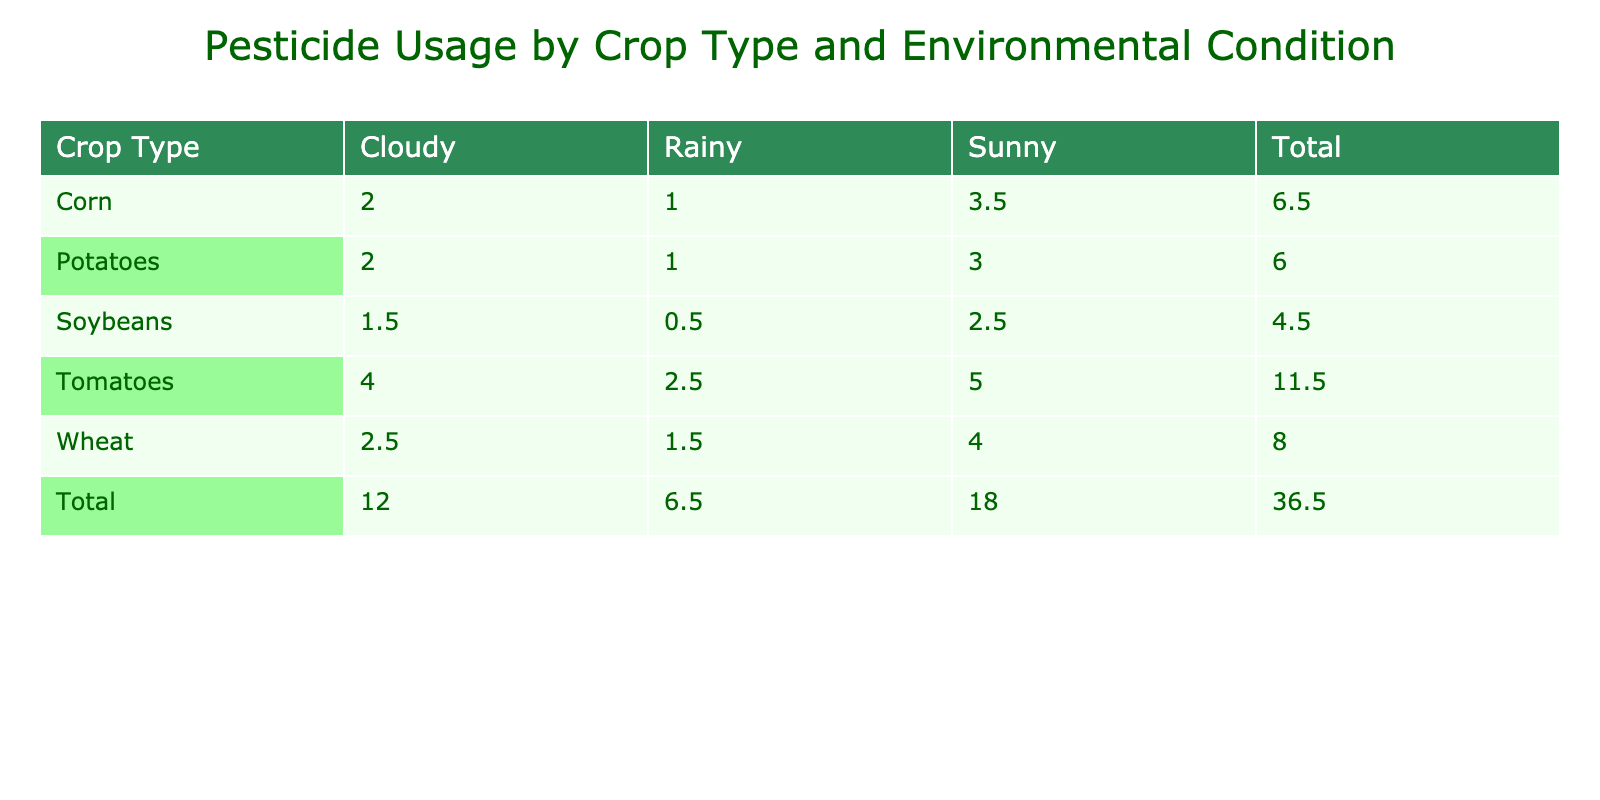What is the pesticide usage for Corn on a Sunny day? The table shows that for Corn under Sunny conditions, the pesticide usage is listed as 3.5 liters per acre.
Answer: 3.5 liters per acre Which crop type has the highest pesticide usage on Cloudy days? Referring to the table, Wheat has a pesticide usage of 2.5 liters per acre while Corn and Soybeans have lower values. Thus, Wheat has the highest usage on Cloudy days.
Answer: Wheat What is the total pesticide usage for Potatoes? To find the total usage for Potatoes, we add the values from the table: Sunny (3.0) + Cloudy (2.0) + Rainy (1.0) = 6.0 liters per acre.
Answer: 6.0 liters per acre Is Tomato pesticide usage higher than Soybeans on Rainy days? Pesticide usage for Tomatoes on Rainy days is 2.5 liters per acre, while for Soybeans it is 0.5 liters per acre. Since 2.5 is greater than 0.5, the answer is yes.
Answer: Yes What is the average pesticide usage for Wheat? The usage values for Wheat are: Sunny (4.0), Cloudy (2.5), and Rainy (1.5). First, sum these values: 4.0 + 2.5 + 1.5 = 8.0. Then, divide by the number of entries (3): 8.0 / 3 = 2.67 liters per acre.
Answer: 2.67 liters per acre Which environmental condition results in the lowest pesticide usage for Corn? By examining the table, we see Corn has its lowest usage under Rainy conditions at 1.0 liters per acre, compared to Sunny (3.5) and Cloudy (2.0).
Answer: Rainy What is the difference in pesticide usage between Tomatoes and Wheat on Sunny days? The usage for Tomatoes on Sunny days is 5.0 liters per acre, and for Wheat, it is 4.0 liters. The difference is 5.0 - 4.0 = 1.0 liters per acre.
Answer: 1.0 liter per acre For which crop type does the pesticide usage decrease most significantly from Sunny to Rainy conditions? By examining the decreases: Corn (3.5 to 1.0 = 2.5), Soybeans (2.5 to 0.5 = 2.0), Wheat (4.0 to 1.5 = 2.5), and Tomatoes (5.0 to 2.5 = 2.5). The largest decrease is for Corn, which decreased by 2.5 liters.
Answer: Corn 